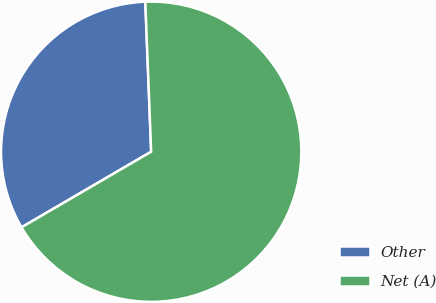Convert chart to OTSL. <chart><loc_0><loc_0><loc_500><loc_500><pie_chart><fcel>Other<fcel>Net (A)<nl><fcel>32.78%<fcel>67.22%<nl></chart> 